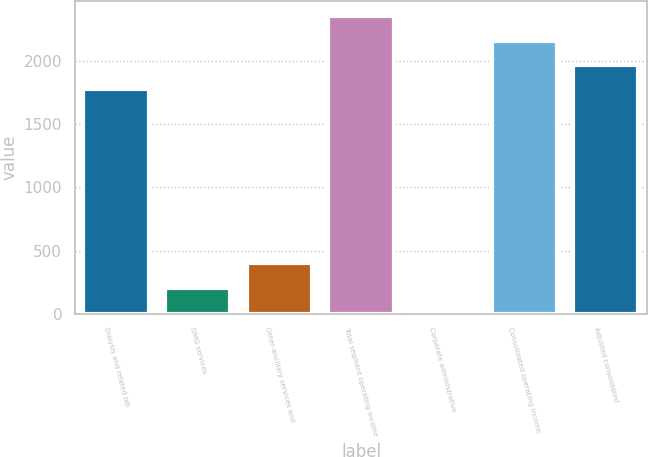Convert chart. <chart><loc_0><loc_0><loc_500><loc_500><bar_chart><fcel>Dialysis and related lab<fcel>DMG services<fcel>Other-ancillary services and<fcel>Total segment operating income<fcel>Corporate administrative<fcel>Consolidated operating income<fcel>Adjusted consolidated<nl><fcel>1777<fcel>206.6<fcel>399.2<fcel>2354.8<fcel>14<fcel>2162.2<fcel>1969.6<nl></chart> 